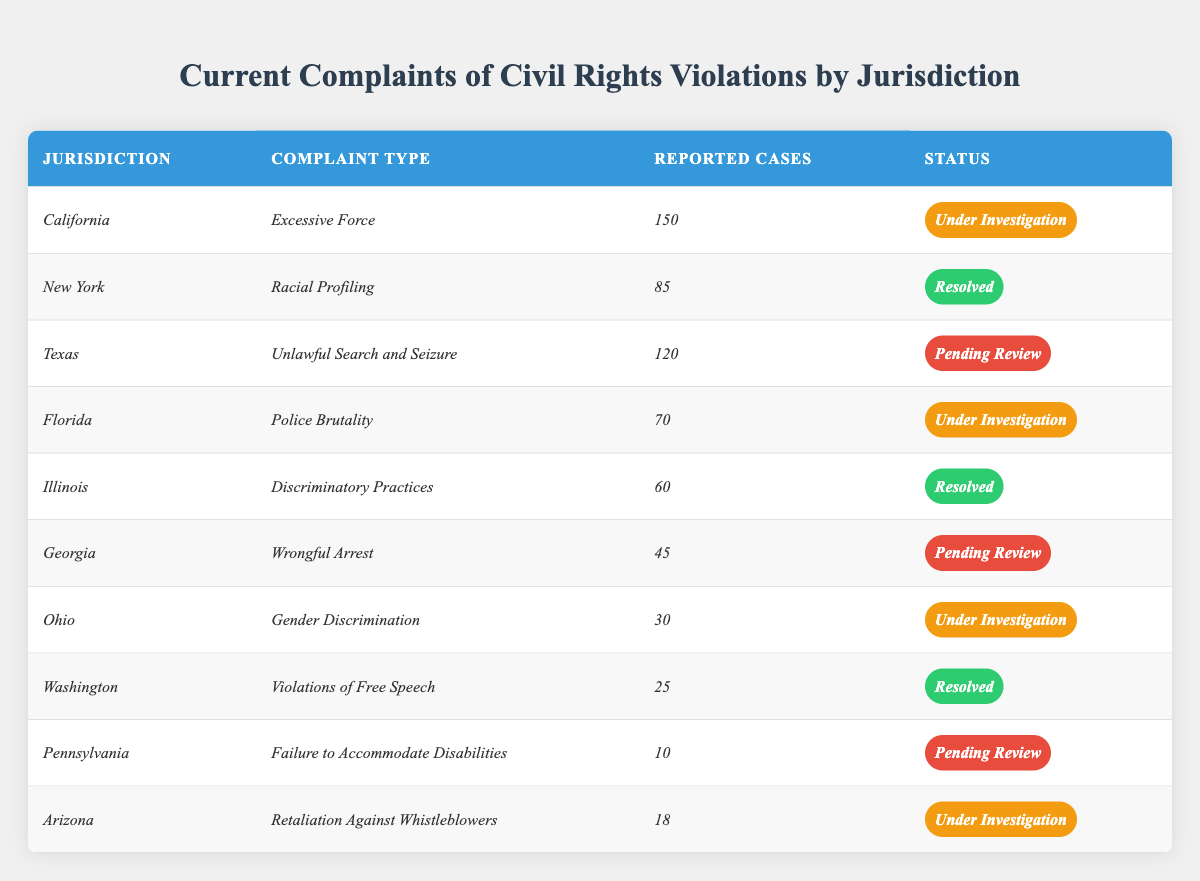What is the total number of reported cases across all jurisdictions? By adding up all the reported cases from each jurisdiction: 150 (California) + 85 (New York) + 120 (Texas) + 70 (Florida) + 60 (Illinois) + 45 (Georgia) + 30 (Ohio) + 25 (Washington) + 10 (Pennsylvania) + 18 (Arizona) =  693
Answer: 693 How many complaints are still under investigation? There are 4 jurisdictions with complaints under investigation: California (150), Florida (70), Ohio (30), and Arizona (18). So, the total reported cases under investigation is: 150 + 70 + 30 + 18 = 268
Answer: 268 What percentage of complaints in New York have been resolved? There is 1 resolved case out of 1 reported case in New York. To find the percentage, (85 / 85) * 100 = 100%.
Answer: 100% Is there any jurisdiction with complaints of "Gender Discrimination"? Yes, Ohio has a complaint of "Gender Discrimination".
Answer: Yes What is the status of the complaint types in Texas, Florida, and Georgia? The statuses are: Texas (Pending Review), Florida (Under Investigation), Georgia (Pending Review).
Answer: Pending Review, Under Investigation, Pending Review Which jurisdiction has reported the most cases, and what is the complaint type? California has the most reported cases (150) for the complaint type "Excessive Force".
Answer: California, Excessive Force What is the average number of reported cases from jurisdictions with a status of "Resolved"? The jurisdictions with resolved statuses are New York (85), Illinois (60), and Washington (25). The average is (85 + 60 + 25) / 3 = 56.67, rounded to 57.
Answer: 57 Which complaint type has the least number of reported cases, and what is its status? The complaint type with the least reported cases is "Failure to Accommodate Disabilities" with 10 cases, and its status is Pending Review.
Answer: Failure to Accommodate Disabilities, Pending Review How many total complaints are pending review compared to those resolved? There are 3 pending review complaints (Texas, Georgia, Pennsylvania) with a total of 175 cases. There are 3 resolved complaints (New York, Illinois, Washington) with a total of 170 cases.
Answer: 175 vs 170 Is the problem of "Racial Profiling" resolved in New York? Yes, the status of the complaint type "Racial Profiling" in New York is resolved.
Answer: Yes 